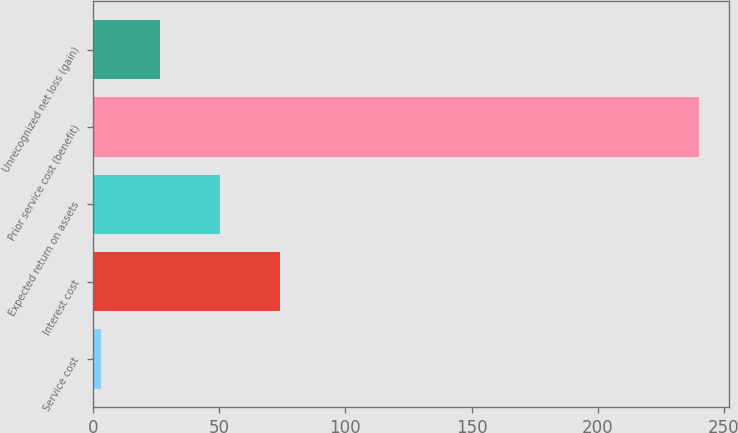Convert chart to OTSL. <chart><loc_0><loc_0><loc_500><loc_500><bar_chart><fcel>Service cost<fcel>Interest cost<fcel>Expected return on assets<fcel>Prior service cost (benefit)<fcel>Unrecognized net loss (gain)<nl><fcel>3<fcel>74.1<fcel>50.4<fcel>240<fcel>26.7<nl></chart> 